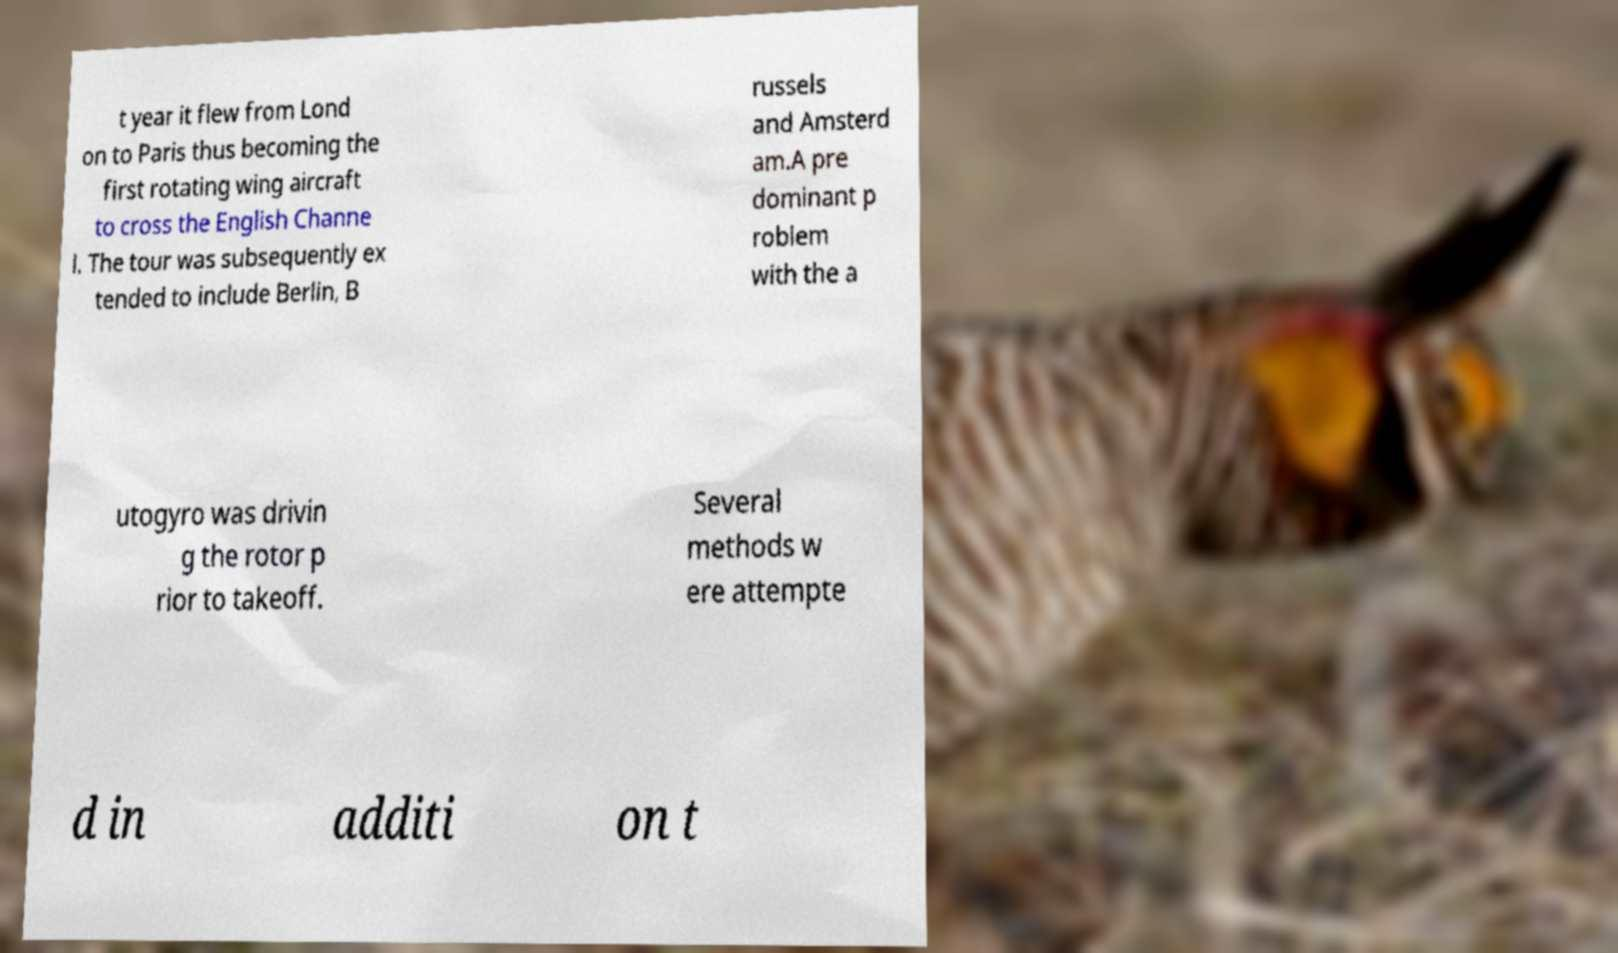I need the written content from this picture converted into text. Can you do that? t year it flew from Lond on to Paris thus becoming the first rotating wing aircraft to cross the English Channe l. The tour was subsequently ex tended to include Berlin, B russels and Amsterd am.A pre dominant p roblem with the a utogyro was drivin g the rotor p rior to takeoff. Several methods w ere attempte d in additi on t 